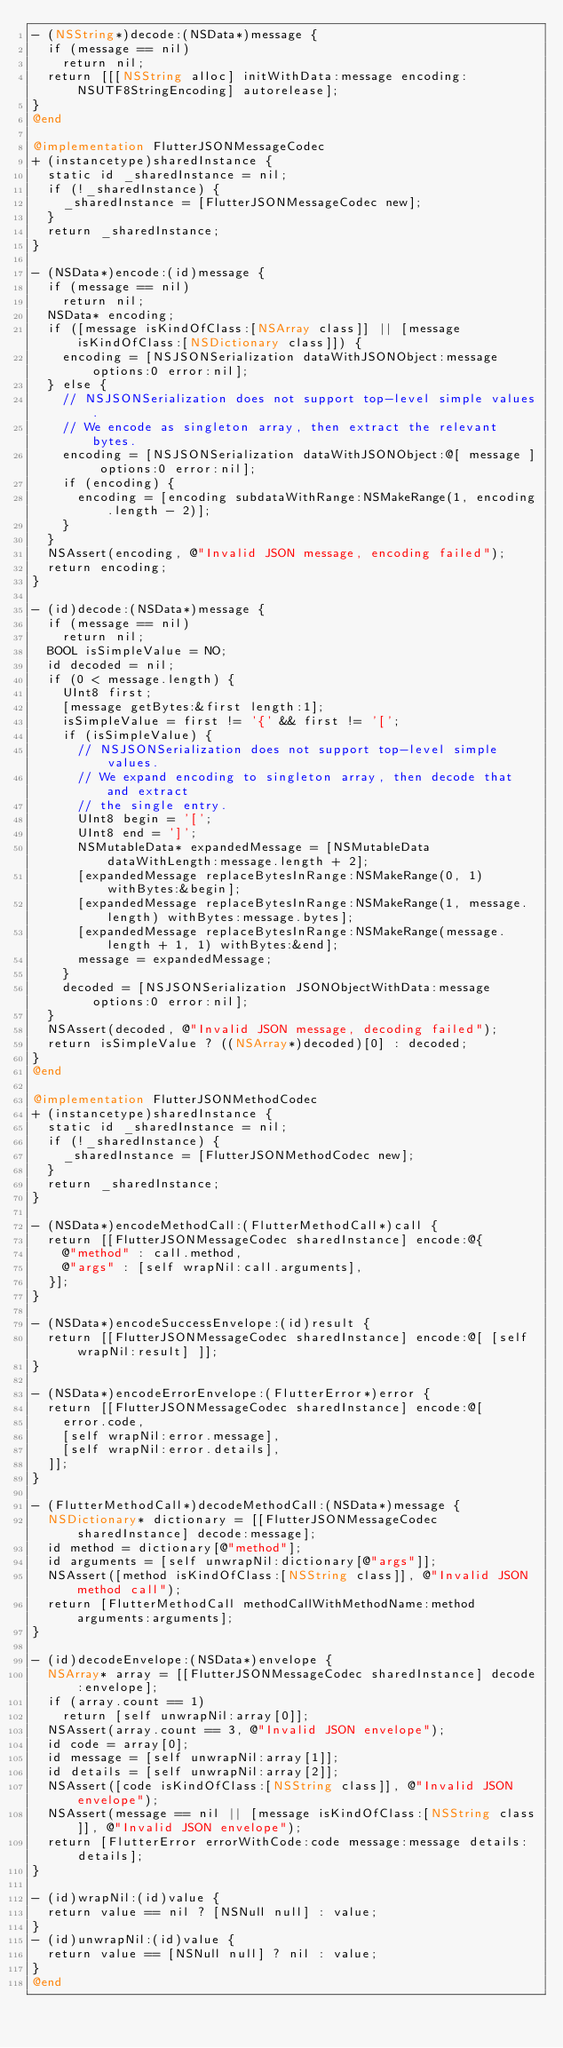Convert code to text. <code><loc_0><loc_0><loc_500><loc_500><_ObjectiveC_>- (NSString*)decode:(NSData*)message {
  if (message == nil)
    return nil;
  return [[[NSString alloc] initWithData:message encoding:NSUTF8StringEncoding] autorelease];
}
@end

@implementation FlutterJSONMessageCodec
+ (instancetype)sharedInstance {
  static id _sharedInstance = nil;
  if (!_sharedInstance) {
    _sharedInstance = [FlutterJSONMessageCodec new];
  }
  return _sharedInstance;
}

- (NSData*)encode:(id)message {
  if (message == nil)
    return nil;
  NSData* encoding;
  if ([message isKindOfClass:[NSArray class]] || [message isKindOfClass:[NSDictionary class]]) {
    encoding = [NSJSONSerialization dataWithJSONObject:message options:0 error:nil];
  } else {
    // NSJSONSerialization does not support top-level simple values.
    // We encode as singleton array, then extract the relevant bytes.
    encoding = [NSJSONSerialization dataWithJSONObject:@[ message ] options:0 error:nil];
    if (encoding) {
      encoding = [encoding subdataWithRange:NSMakeRange(1, encoding.length - 2)];
    }
  }
  NSAssert(encoding, @"Invalid JSON message, encoding failed");
  return encoding;
}

- (id)decode:(NSData*)message {
  if (message == nil)
    return nil;
  BOOL isSimpleValue = NO;
  id decoded = nil;
  if (0 < message.length) {
    UInt8 first;
    [message getBytes:&first length:1];
    isSimpleValue = first != '{' && first != '[';
    if (isSimpleValue) {
      // NSJSONSerialization does not support top-level simple values.
      // We expand encoding to singleton array, then decode that and extract
      // the single entry.
      UInt8 begin = '[';
      UInt8 end = ']';
      NSMutableData* expandedMessage = [NSMutableData dataWithLength:message.length + 2];
      [expandedMessage replaceBytesInRange:NSMakeRange(0, 1) withBytes:&begin];
      [expandedMessage replaceBytesInRange:NSMakeRange(1, message.length) withBytes:message.bytes];
      [expandedMessage replaceBytesInRange:NSMakeRange(message.length + 1, 1) withBytes:&end];
      message = expandedMessage;
    }
    decoded = [NSJSONSerialization JSONObjectWithData:message options:0 error:nil];
  }
  NSAssert(decoded, @"Invalid JSON message, decoding failed");
  return isSimpleValue ? ((NSArray*)decoded)[0] : decoded;
}
@end

@implementation FlutterJSONMethodCodec
+ (instancetype)sharedInstance {
  static id _sharedInstance = nil;
  if (!_sharedInstance) {
    _sharedInstance = [FlutterJSONMethodCodec new];
  }
  return _sharedInstance;
}

- (NSData*)encodeMethodCall:(FlutterMethodCall*)call {
  return [[FlutterJSONMessageCodec sharedInstance] encode:@{
    @"method" : call.method,
    @"args" : [self wrapNil:call.arguments],
  }];
}

- (NSData*)encodeSuccessEnvelope:(id)result {
  return [[FlutterJSONMessageCodec sharedInstance] encode:@[ [self wrapNil:result] ]];
}

- (NSData*)encodeErrorEnvelope:(FlutterError*)error {
  return [[FlutterJSONMessageCodec sharedInstance] encode:@[
    error.code,
    [self wrapNil:error.message],
    [self wrapNil:error.details],
  ]];
}

- (FlutterMethodCall*)decodeMethodCall:(NSData*)message {
  NSDictionary* dictionary = [[FlutterJSONMessageCodec sharedInstance] decode:message];
  id method = dictionary[@"method"];
  id arguments = [self unwrapNil:dictionary[@"args"]];
  NSAssert([method isKindOfClass:[NSString class]], @"Invalid JSON method call");
  return [FlutterMethodCall methodCallWithMethodName:method arguments:arguments];
}

- (id)decodeEnvelope:(NSData*)envelope {
  NSArray* array = [[FlutterJSONMessageCodec sharedInstance] decode:envelope];
  if (array.count == 1)
    return [self unwrapNil:array[0]];
  NSAssert(array.count == 3, @"Invalid JSON envelope");
  id code = array[0];
  id message = [self unwrapNil:array[1]];
  id details = [self unwrapNil:array[2]];
  NSAssert([code isKindOfClass:[NSString class]], @"Invalid JSON envelope");
  NSAssert(message == nil || [message isKindOfClass:[NSString class]], @"Invalid JSON envelope");
  return [FlutterError errorWithCode:code message:message details:details];
}

- (id)wrapNil:(id)value {
  return value == nil ? [NSNull null] : value;
}
- (id)unwrapNil:(id)value {
  return value == [NSNull null] ? nil : value;
}
@end
</code> 